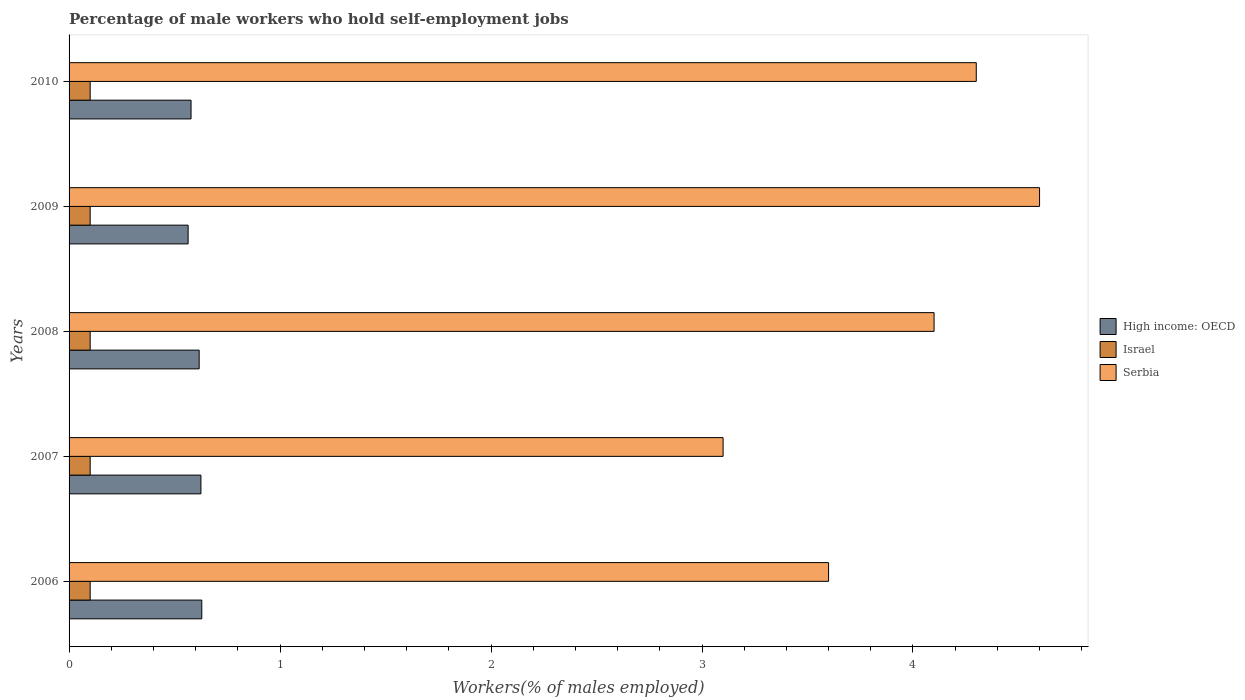How many different coloured bars are there?
Your answer should be very brief. 3. How many groups of bars are there?
Offer a very short reply. 5. Are the number of bars on each tick of the Y-axis equal?
Provide a short and direct response. Yes. How many bars are there on the 3rd tick from the bottom?
Give a very brief answer. 3. What is the label of the 1st group of bars from the top?
Make the answer very short. 2010. What is the percentage of self-employed male workers in High income: OECD in 2007?
Offer a terse response. 0.62. Across all years, what is the maximum percentage of self-employed male workers in Serbia?
Your response must be concise. 4.6. Across all years, what is the minimum percentage of self-employed male workers in Israel?
Offer a very short reply. 0.1. In which year was the percentage of self-employed male workers in High income: OECD maximum?
Your answer should be very brief. 2006. What is the total percentage of self-employed male workers in High income: OECD in the graph?
Ensure brevity in your answer.  3.01. What is the difference between the percentage of self-employed male workers in Israel in 2008 and that in 2010?
Your response must be concise. 0. What is the difference between the percentage of self-employed male workers in Serbia in 2006 and the percentage of self-employed male workers in High income: OECD in 2009?
Provide a succinct answer. 3.04. What is the average percentage of self-employed male workers in Israel per year?
Provide a succinct answer. 0.1. In the year 2010, what is the difference between the percentage of self-employed male workers in Israel and percentage of self-employed male workers in Serbia?
Your response must be concise. -4.2. What is the ratio of the percentage of self-employed male workers in Serbia in 2007 to that in 2009?
Provide a short and direct response. 0.67. Is the percentage of self-employed male workers in High income: OECD in 2006 less than that in 2010?
Offer a very short reply. No. What is the difference between the highest and the second highest percentage of self-employed male workers in Serbia?
Provide a short and direct response. 0.3. What is the difference between the highest and the lowest percentage of self-employed male workers in Israel?
Offer a terse response. 0. Is the sum of the percentage of self-employed male workers in Serbia in 2008 and 2010 greater than the maximum percentage of self-employed male workers in High income: OECD across all years?
Keep it short and to the point. Yes. What does the 3rd bar from the top in 2009 represents?
Ensure brevity in your answer.  High income: OECD. What does the 3rd bar from the bottom in 2006 represents?
Make the answer very short. Serbia. Is it the case that in every year, the sum of the percentage of self-employed male workers in Serbia and percentage of self-employed male workers in High income: OECD is greater than the percentage of self-employed male workers in Israel?
Ensure brevity in your answer.  Yes. What is the difference between two consecutive major ticks on the X-axis?
Your answer should be compact. 1. Does the graph contain any zero values?
Offer a terse response. No. What is the title of the graph?
Offer a terse response. Percentage of male workers who hold self-employment jobs. What is the label or title of the X-axis?
Offer a terse response. Workers(% of males employed). What is the Workers(% of males employed) of High income: OECD in 2006?
Keep it short and to the point. 0.63. What is the Workers(% of males employed) of Israel in 2006?
Ensure brevity in your answer.  0.1. What is the Workers(% of males employed) of Serbia in 2006?
Your response must be concise. 3.6. What is the Workers(% of males employed) of High income: OECD in 2007?
Ensure brevity in your answer.  0.62. What is the Workers(% of males employed) in Israel in 2007?
Give a very brief answer. 0.1. What is the Workers(% of males employed) of Serbia in 2007?
Offer a very short reply. 3.1. What is the Workers(% of males employed) of High income: OECD in 2008?
Provide a succinct answer. 0.62. What is the Workers(% of males employed) of Israel in 2008?
Make the answer very short. 0.1. What is the Workers(% of males employed) of Serbia in 2008?
Offer a terse response. 4.1. What is the Workers(% of males employed) in High income: OECD in 2009?
Ensure brevity in your answer.  0.56. What is the Workers(% of males employed) in Israel in 2009?
Offer a terse response. 0.1. What is the Workers(% of males employed) in Serbia in 2009?
Provide a succinct answer. 4.6. What is the Workers(% of males employed) in High income: OECD in 2010?
Give a very brief answer. 0.58. What is the Workers(% of males employed) of Israel in 2010?
Provide a succinct answer. 0.1. What is the Workers(% of males employed) of Serbia in 2010?
Offer a very short reply. 4.3. Across all years, what is the maximum Workers(% of males employed) of High income: OECD?
Offer a terse response. 0.63. Across all years, what is the maximum Workers(% of males employed) in Israel?
Your response must be concise. 0.1. Across all years, what is the maximum Workers(% of males employed) of Serbia?
Your response must be concise. 4.6. Across all years, what is the minimum Workers(% of males employed) in High income: OECD?
Ensure brevity in your answer.  0.56. Across all years, what is the minimum Workers(% of males employed) in Israel?
Make the answer very short. 0.1. Across all years, what is the minimum Workers(% of males employed) in Serbia?
Make the answer very short. 3.1. What is the total Workers(% of males employed) in High income: OECD in the graph?
Your response must be concise. 3.01. What is the difference between the Workers(% of males employed) in High income: OECD in 2006 and that in 2007?
Provide a succinct answer. 0. What is the difference between the Workers(% of males employed) in Israel in 2006 and that in 2007?
Make the answer very short. 0. What is the difference between the Workers(% of males employed) of Serbia in 2006 and that in 2007?
Offer a very short reply. 0.5. What is the difference between the Workers(% of males employed) in High income: OECD in 2006 and that in 2008?
Your answer should be very brief. 0.01. What is the difference between the Workers(% of males employed) of High income: OECD in 2006 and that in 2009?
Your answer should be very brief. 0.06. What is the difference between the Workers(% of males employed) in Israel in 2006 and that in 2009?
Provide a short and direct response. 0. What is the difference between the Workers(% of males employed) in High income: OECD in 2006 and that in 2010?
Give a very brief answer. 0.05. What is the difference between the Workers(% of males employed) in Israel in 2006 and that in 2010?
Offer a terse response. 0. What is the difference between the Workers(% of males employed) of Serbia in 2006 and that in 2010?
Give a very brief answer. -0.7. What is the difference between the Workers(% of males employed) of High income: OECD in 2007 and that in 2008?
Ensure brevity in your answer.  0.01. What is the difference between the Workers(% of males employed) in High income: OECD in 2007 and that in 2009?
Give a very brief answer. 0.06. What is the difference between the Workers(% of males employed) of Serbia in 2007 and that in 2009?
Your response must be concise. -1.5. What is the difference between the Workers(% of males employed) in High income: OECD in 2007 and that in 2010?
Provide a succinct answer. 0.05. What is the difference between the Workers(% of males employed) of Serbia in 2007 and that in 2010?
Keep it short and to the point. -1.2. What is the difference between the Workers(% of males employed) of High income: OECD in 2008 and that in 2009?
Give a very brief answer. 0.05. What is the difference between the Workers(% of males employed) in High income: OECD in 2008 and that in 2010?
Make the answer very short. 0.04. What is the difference between the Workers(% of males employed) in Israel in 2008 and that in 2010?
Your answer should be very brief. 0. What is the difference between the Workers(% of males employed) in High income: OECD in 2009 and that in 2010?
Ensure brevity in your answer.  -0.01. What is the difference between the Workers(% of males employed) in High income: OECD in 2006 and the Workers(% of males employed) in Israel in 2007?
Your answer should be compact. 0.53. What is the difference between the Workers(% of males employed) of High income: OECD in 2006 and the Workers(% of males employed) of Serbia in 2007?
Provide a short and direct response. -2.47. What is the difference between the Workers(% of males employed) in High income: OECD in 2006 and the Workers(% of males employed) in Israel in 2008?
Offer a terse response. 0.53. What is the difference between the Workers(% of males employed) of High income: OECD in 2006 and the Workers(% of males employed) of Serbia in 2008?
Offer a very short reply. -3.47. What is the difference between the Workers(% of males employed) in High income: OECD in 2006 and the Workers(% of males employed) in Israel in 2009?
Provide a succinct answer. 0.53. What is the difference between the Workers(% of males employed) of High income: OECD in 2006 and the Workers(% of males employed) of Serbia in 2009?
Make the answer very short. -3.97. What is the difference between the Workers(% of males employed) of Israel in 2006 and the Workers(% of males employed) of Serbia in 2009?
Provide a short and direct response. -4.5. What is the difference between the Workers(% of males employed) in High income: OECD in 2006 and the Workers(% of males employed) in Israel in 2010?
Make the answer very short. 0.53. What is the difference between the Workers(% of males employed) in High income: OECD in 2006 and the Workers(% of males employed) in Serbia in 2010?
Give a very brief answer. -3.67. What is the difference between the Workers(% of males employed) of High income: OECD in 2007 and the Workers(% of males employed) of Israel in 2008?
Provide a succinct answer. 0.53. What is the difference between the Workers(% of males employed) in High income: OECD in 2007 and the Workers(% of males employed) in Serbia in 2008?
Offer a very short reply. -3.48. What is the difference between the Workers(% of males employed) of High income: OECD in 2007 and the Workers(% of males employed) of Israel in 2009?
Give a very brief answer. 0.53. What is the difference between the Workers(% of males employed) in High income: OECD in 2007 and the Workers(% of males employed) in Serbia in 2009?
Your answer should be very brief. -3.98. What is the difference between the Workers(% of males employed) of Israel in 2007 and the Workers(% of males employed) of Serbia in 2009?
Give a very brief answer. -4.5. What is the difference between the Workers(% of males employed) of High income: OECD in 2007 and the Workers(% of males employed) of Israel in 2010?
Keep it short and to the point. 0.53. What is the difference between the Workers(% of males employed) of High income: OECD in 2007 and the Workers(% of males employed) of Serbia in 2010?
Your response must be concise. -3.67. What is the difference between the Workers(% of males employed) in High income: OECD in 2008 and the Workers(% of males employed) in Israel in 2009?
Ensure brevity in your answer.  0.52. What is the difference between the Workers(% of males employed) in High income: OECD in 2008 and the Workers(% of males employed) in Serbia in 2009?
Provide a succinct answer. -3.98. What is the difference between the Workers(% of males employed) of Israel in 2008 and the Workers(% of males employed) of Serbia in 2009?
Your answer should be very brief. -4.5. What is the difference between the Workers(% of males employed) in High income: OECD in 2008 and the Workers(% of males employed) in Israel in 2010?
Make the answer very short. 0.52. What is the difference between the Workers(% of males employed) in High income: OECD in 2008 and the Workers(% of males employed) in Serbia in 2010?
Your answer should be compact. -3.68. What is the difference between the Workers(% of males employed) in Israel in 2008 and the Workers(% of males employed) in Serbia in 2010?
Give a very brief answer. -4.2. What is the difference between the Workers(% of males employed) in High income: OECD in 2009 and the Workers(% of males employed) in Israel in 2010?
Make the answer very short. 0.46. What is the difference between the Workers(% of males employed) of High income: OECD in 2009 and the Workers(% of males employed) of Serbia in 2010?
Offer a terse response. -3.74. What is the difference between the Workers(% of males employed) of Israel in 2009 and the Workers(% of males employed) of Serbia in 2010?
Provide a succinct answer. -4.2. What is the average Workers(% of males employed) of High income: OECD per year?
Give a very brief answer. 0.6. What is the average Workers(% of males employed) in Israel per year?
Make the answer very short. 0.1. What is the average Workers(% of males employed) in Serbia per year?
Provide a short and direct response. 3.94. In the year 2006, what is the difference between the Workers(% of males employed) in High income: OECD and Workers(% of males employed) in Israel?
Give a very brief answer. 0.53. In the year 2006, what is the difference between the Workers(% of males employed) of High income: OECD and Workers(% of males employed) of Serbia?
Provide a short and direct response. -2.97. In the year 2007, what is the difference between the Workers(% of males employed) of High income: OECD and Workers(% of males employed) of Israel?
Your answer should be compact. 0.53. In the year 2007, what is the difference between the Workers(% of males employed) of High income: OECD and Workers(% of males employed) of Serbia?
Ensure brevity in your answer.  -2.48. In the year 2007, what is the difference between the Workers(% of males employed) of Israel and Workers(% of males employed) of Serbia?
Keep it short and to the point. -3. In the year 2008, what is the difference between the Workers(% of males employed) in High income: OECD and Workers(% of males employed) in Israel?
Your answer should be compact. 0.52. In the year 2008, what is the difference between the Workers(% of males employed) in High income: OECD and Workers(% of males employed) in Serbia?
Your response must be concise. -3.48. In the year 2008, what is the difference between the Workers(% of males employed) in Israel and Workers(% of males employed) in Serbia?
Your response must be concise. -4. In the year 2009, what is the difference between the Workers(% of males employed) in High income: OECD and Workers(% of males employed) in Israel?
Your response must be concise. 0.46. In the year 2009, what is the difference between the Workers(% of males employed) in High income: OECD and Workers(% of males employed) in Serbia?
Keep it short and to the point. -4.04. In the year 2010, what is the difference between the Workers(% of males employed) of High income: OECD and Workers(% of males employed) of Israel?
Offer a very short reply. 0.48. In the year 2010, what is the difference between the Workers(% of males employed) of High income: OECD and Workers(% of males employed) of Serbia?
Offer a very short reply. -3.72. In the year 2010, what is the difference between the Workers(% of males employed) in Israel and Workers(% of males employed) in Serbia?
Offer a terse response. -4.2. What is the ratio of the Workers(% of males employed) in High income: OECD in 2006 to that in 2007?
Provide a succinct answer. 1.01. What is the ratio of the Workers(% of males employed) in Serbia in 2006 to that in 2007?
Your answer should be very brief. 1.16. What is the ratio of the Workers(% of males employed) of High income: OECD in 2006 to that in 2008?
Your response must be concise. 1.02. What is the ratio of the Workers(% of males employed) of Serbia in 2006 to that in 2008?
Keep it short and to the point. 0.88. What is the ratio of the Workers(% of males employed) of High income: OECD in 2006 to that in 2009?
Offer a very short reply. 1.11. What is the ratio of the Workers(% of males employed) in Israel in 2006 to that in 2009?
Ensure brevity in your answer.  1. What is the ratio of the Workers(% of males employed) of Serbia in 2006 to that in 2009?
Provide a succinct answer. 0.78. What is the ratio of the Workers(% of males employed) of High income: OECD in 2006 to that in 2010?
Offer a terse response. 1.09. What is the ratio of the Workers(% of males employed) in Israel in 2006 to that in 2010?
Provide a succinct answer. 1. What is the ratio of the Workers(% of males employed) in Serbia in 2006 to that in 2010?
Provide a short and direct response. 0.84. What is the ratio of the Workers(% of males employed) in High income: OECD in 2007 to that in 2008?
Ensure brevity in your answer.  1.01. What is the ratio of the Workers(% of males employed) in Serbia in 2007 to that in 2008?
Offer a terse response. 0.76. What is the ratio of the Workers(% of males employed) in High income: OECD in 2007 to that in 2009?
Make the answer very short. 1.11. What is the ratio of the Workers(% of males employed) of Serbia in 2007 to that in 2009?
Offer a very short reply. 0.67. What is the ratio of the Workers(% of males employed) in High income: OECD in 2007 to that in 2010?
Your answer should be very brief. 1.08. What is the ratio of the Workers(% of males employed) of Serbia in 2007 to that in 2010?
Provide a short and direct response. 0.72. What is the ratio of the Workers(% of males employed) in High income: OECD in 2008 to that in 2009?
Offer a terse response. 1.09. What is the ratio of the Workers(% of males employed) of Israel in 2008 to that in 2009?
Ensure brevity in your answer.  1. What is the ratio of the Workers(% of males employed) in Serbia in 2008 to that in 2009?
Offer a very short reply. 0.89. What is the ratio of the Workers(% of males employed) of High income: OECD in 2008 to that in 2010?
Offer a very short reply. 1.07. What is the ratio of the Workers(% of males employed) of Israel in 2008 to that in 2010?
Offer a very short reply. 1. What is the ratio of the Workers(% of males employed) of Serbia in 2008 to that in 2010?
Give a very brief answer. 0.95. What is the ratio of the Workers(% of males employed) in High income: OECD in 2009 to that in 2010?
Your response must be concise. 0.98. What is the ratio of the Workers(% of males employed) in Serbia in 2009 to that in 2010?
Your response must be concise. 1.07. What is the difference between the highest and the second highest Workers(% of males employed) in High income: OECD?
Provide a succinct answer. 0. What is the difference between the highest and the second highest Workers(% of males employed) of Israel?
Keep it short and to the point. 0. What is the difference between the highest and the second highest Workers(% of males employed) in Serbia?
Your answer should be very brief. 0.3. What is the difference between the highest and the lowest Workers(% of males employed) in High income: OECD?
Offer a terse response. 0.06. What is the difference between the highest and the lowest Workers(% of males employed) in Israel?
Your response must be concise. 0. What is the difference between the highest and the lowest Workers(% of males employed) of Serbia?
Provide a succinct answer. 1.5. 